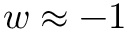Convert formula to latex. <formula><loc_0><loc_0><loc_500><loc_500>w \approx - 1</formula> 